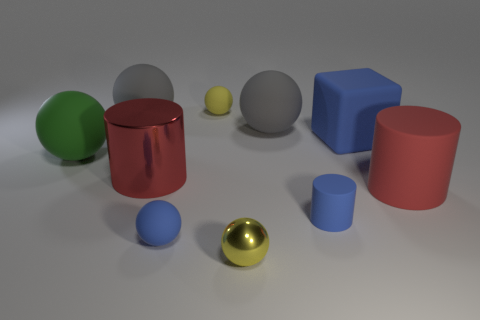There is a yellow sphere that is in front of the big green sphere; is it the same size as the metallic thing behind the large red matte thing?
Your answer should be very brief. No. Are there more blue matte things in front of the large blue rubber block than matte spheres that are behind the tiny blue matte cylinder?
Your response must be concise. No. How many other things are there of the same color as the small rubber cylinder?
Your answer should be compact. 2. Do the tiny shiny sphere and the small matte thing that is in front of the small blue cylinder have the same color?
Offer a terse response. No. How many large blue blocks are to the right of the cylinder that is right of the big blue rubber cube?
Ensure brevity in your answer.  0. Is there any other thing that is the same material as the large green sphere?
Provide a short and direct response. Yes. The red thing that is in front of the large cylinder left of the small blue thing right of the tiny yellow metallic ball is made of what material?
Make the answer very short. Rubber. There is a sphere that is both in front of the green ball and behind the tiny yellow metallic object; what material is it?
Offer a terse response. Rubber. What number of gray objects are the same shape as the yellow matte object?
Offer a very short reply. 2. There is a gray matte object that is to the left of the cylinder that is to the left of the tiny rubber cylinder; how big is it?
Offer a very short reply. Large. 